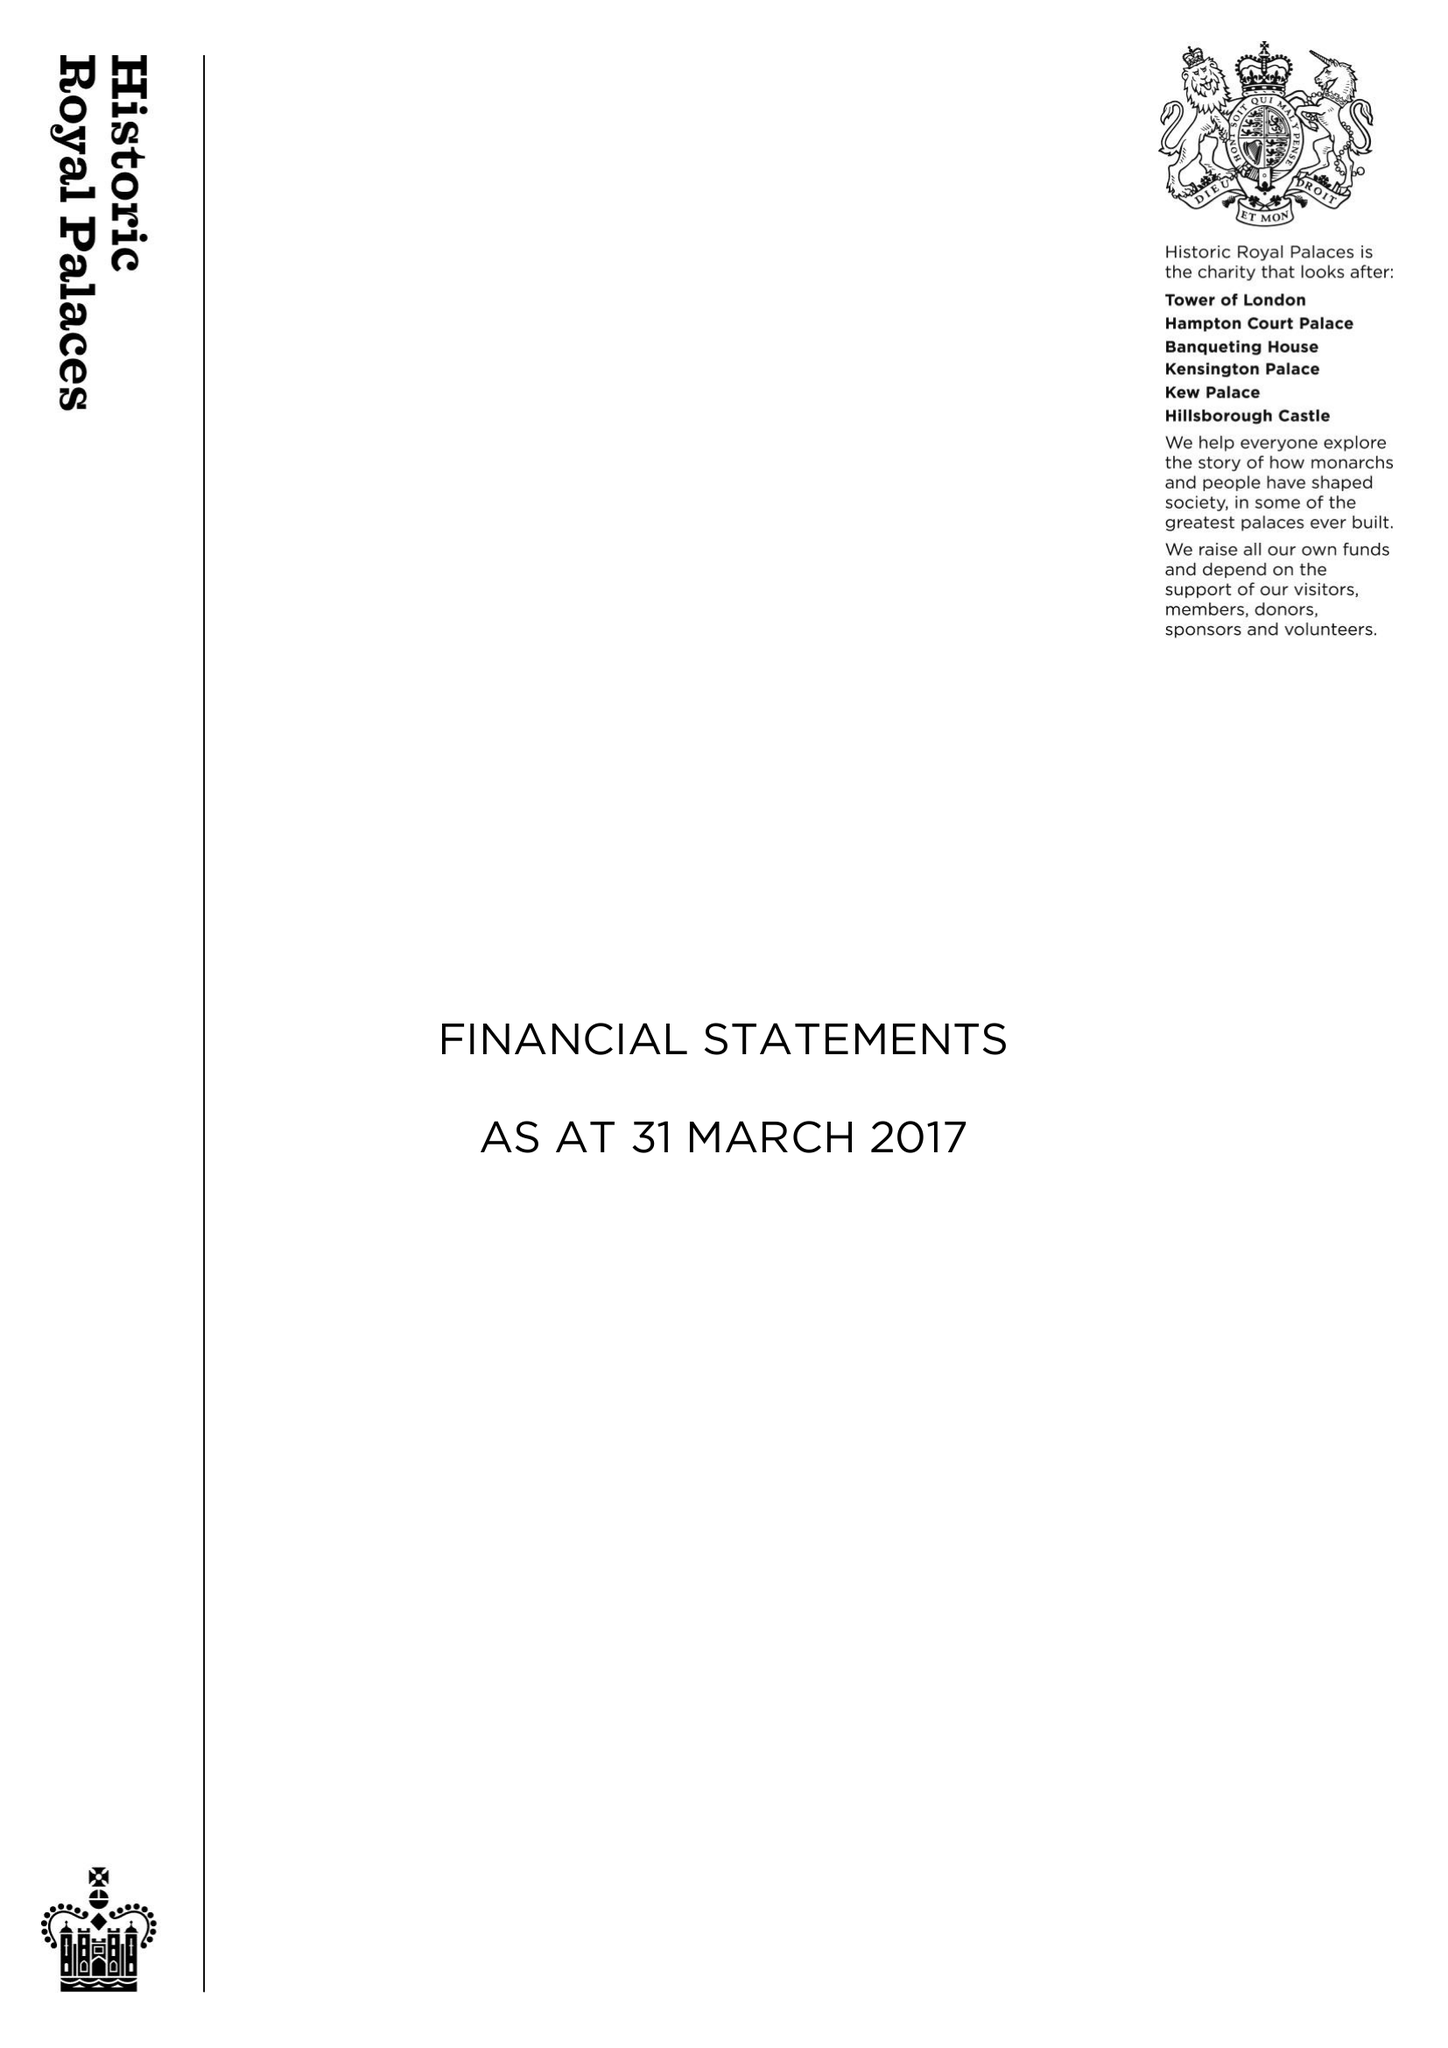What is the value for the charity_number?
Answer the question using a single word or phrase. 1068852 